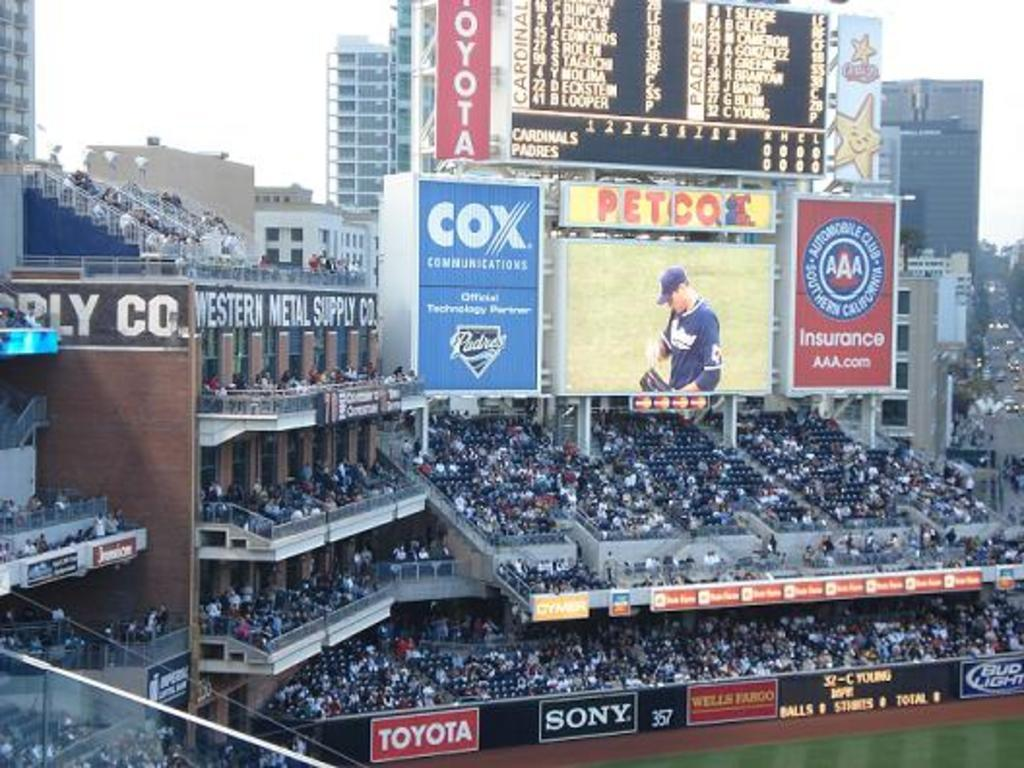Provide a one-sentence caption for the provided image. A Cox advertisement is above the fans at the stadium. 